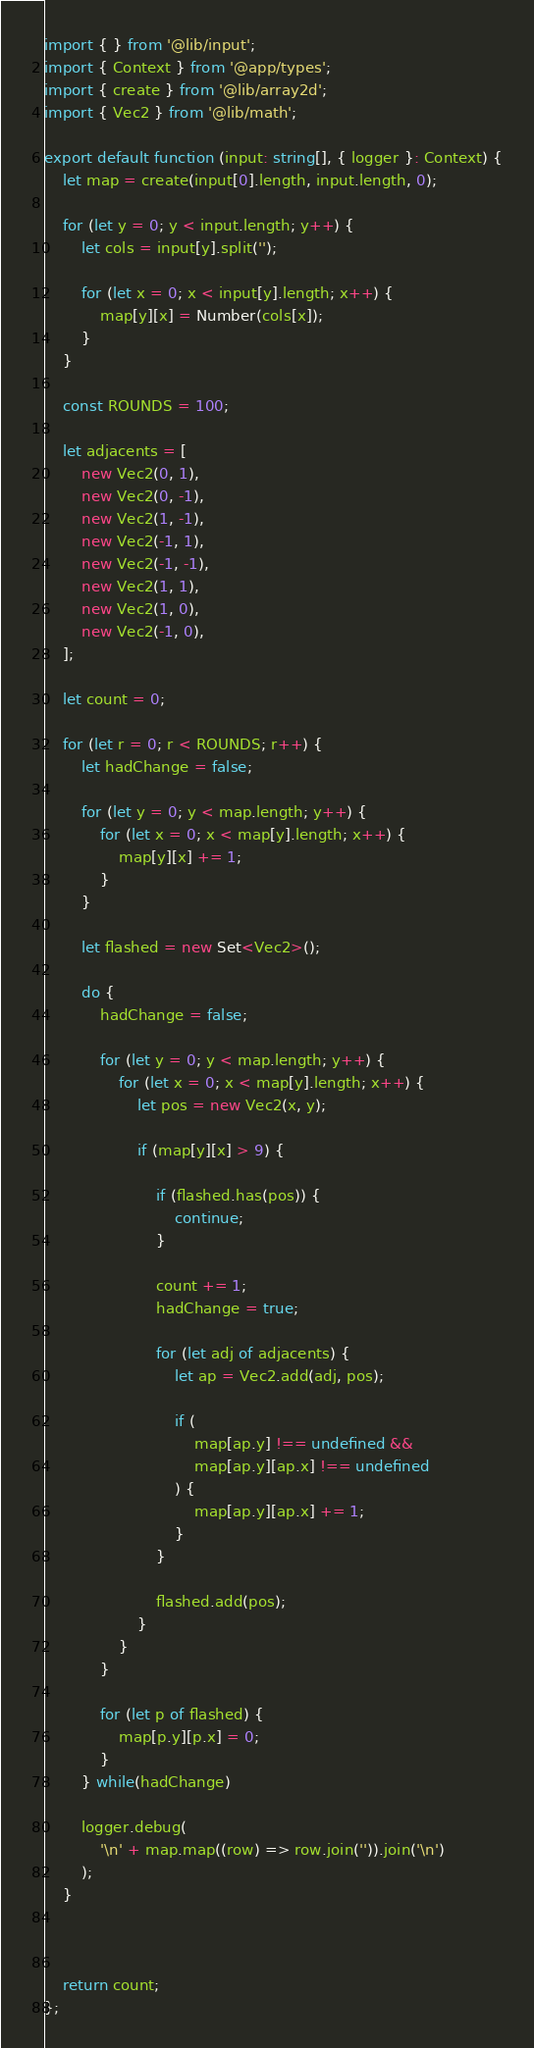Convert code to text. <code><loc_0><loc_0><loc_500><loc_500><_TypeScript_>import { } from '@lib/input';
import { Context } from '@app/types';
import { create } from '@lib/array2d';
import { Vec2 } from '@lib/math';

export default function (input: string[], { logger }: Context) {
    let map = create(input[0].length, input.length, 0);

    for (let y = 0; y < input.length; y++) {
        let cols = input[y].split('');

        for (let x = 0; x < input[y].length; x++) {
            map[y][x] = Number(cols[x]);
        }
    }

    const ROUNDS = 100;

    let adjacents = [
        new Vec2(0, 1),
        new Vec2(0, -1),
        new Vec2(1, -1),
        new Vec2(-1, 1),
        new Vec2(-1, -1),
        new Vec2(1, 1),
        new Vec2(1, 0),
        new Vec2(-1, 0),
    ];

    let count = 0;

    for (let r = 0; r < ROUNDS; r++) {
        let hadChange = false;

        for (let y = 0; y < map.length; y++) {
            for (let x = 0; x < map[y].length; x++) {
                map[y][x] += 1;
            }
        }
        
        let flashed = new Set<Vec2>();
        
        do {
            hadChange = false;

            for (let y = 0; y < map.length; y++) {
                for (let x = 0; x < map[y].length; x++) {
                    let pos = new Vec2(x, y);

                    if (map[y][x] > 9) {
                        
                        if (flashed.has(pos)) {
                            continue;
                        }

                        count += 1;
                        hadChange = true;

                        for (let adj of adjacents) {
                            let ap = Vec2.add(adj, pos);

                            if (
                                map[ap.y] !== undefined &&
                                map[ap.y][ap.x] !== undefined
                            ) {
                                map[ap.y][ap.x] += 1;
                            }
                        }

                        flashed.add(pos);
                    }
                }
            }

            for (let p of flashed) {
                map[p.y][p.x] = 0;
            }
        } while(hadChange)

        logger.debug(
            '\n' + map.map((row) => row.join('')).join('\n')
        );
    }

    

    return count;
};</code> 